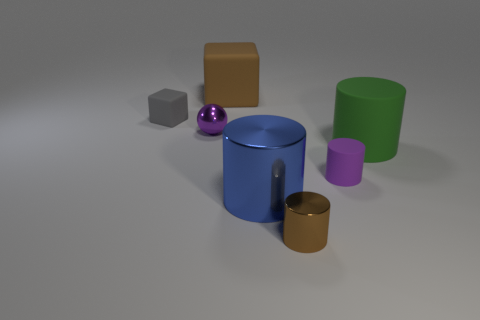There is a cube that is the same size as the green thing; what is it made of?
Offer a terse response. Rubber. What number of metallic things are either small spheres or blue objects?
Provide a succinct answer. 2. The tiny object that is behind the small brown thing and right of the blue metallic thing is what color?
Provide a short and direct response. Purple. There is a tiny purple matte cylinder; how many blue metallic cylinders are left of it?
Your answer should be compact. 1. What is the material of the gray object?
Your answer should be compact. Rubber. There is a big rubber object behind the block left of the block on the right side of the shiny sphere; what color is it?
Keep it short and to the point. Brown. How many other blue objects have the same size as the blue thing?
Your answer should be very brief. 0. There is a tiny thing that is right of the small brown shiny object; what color is it?
Give a very brief answer. Purple. What number of other objects are the same size as the green cylinder?
Your answer should be compact. 2. How big is the matte object that is both behind the tiny purple rubber cylinder and in front of the small gray object?
Make the answer very short. Large. 